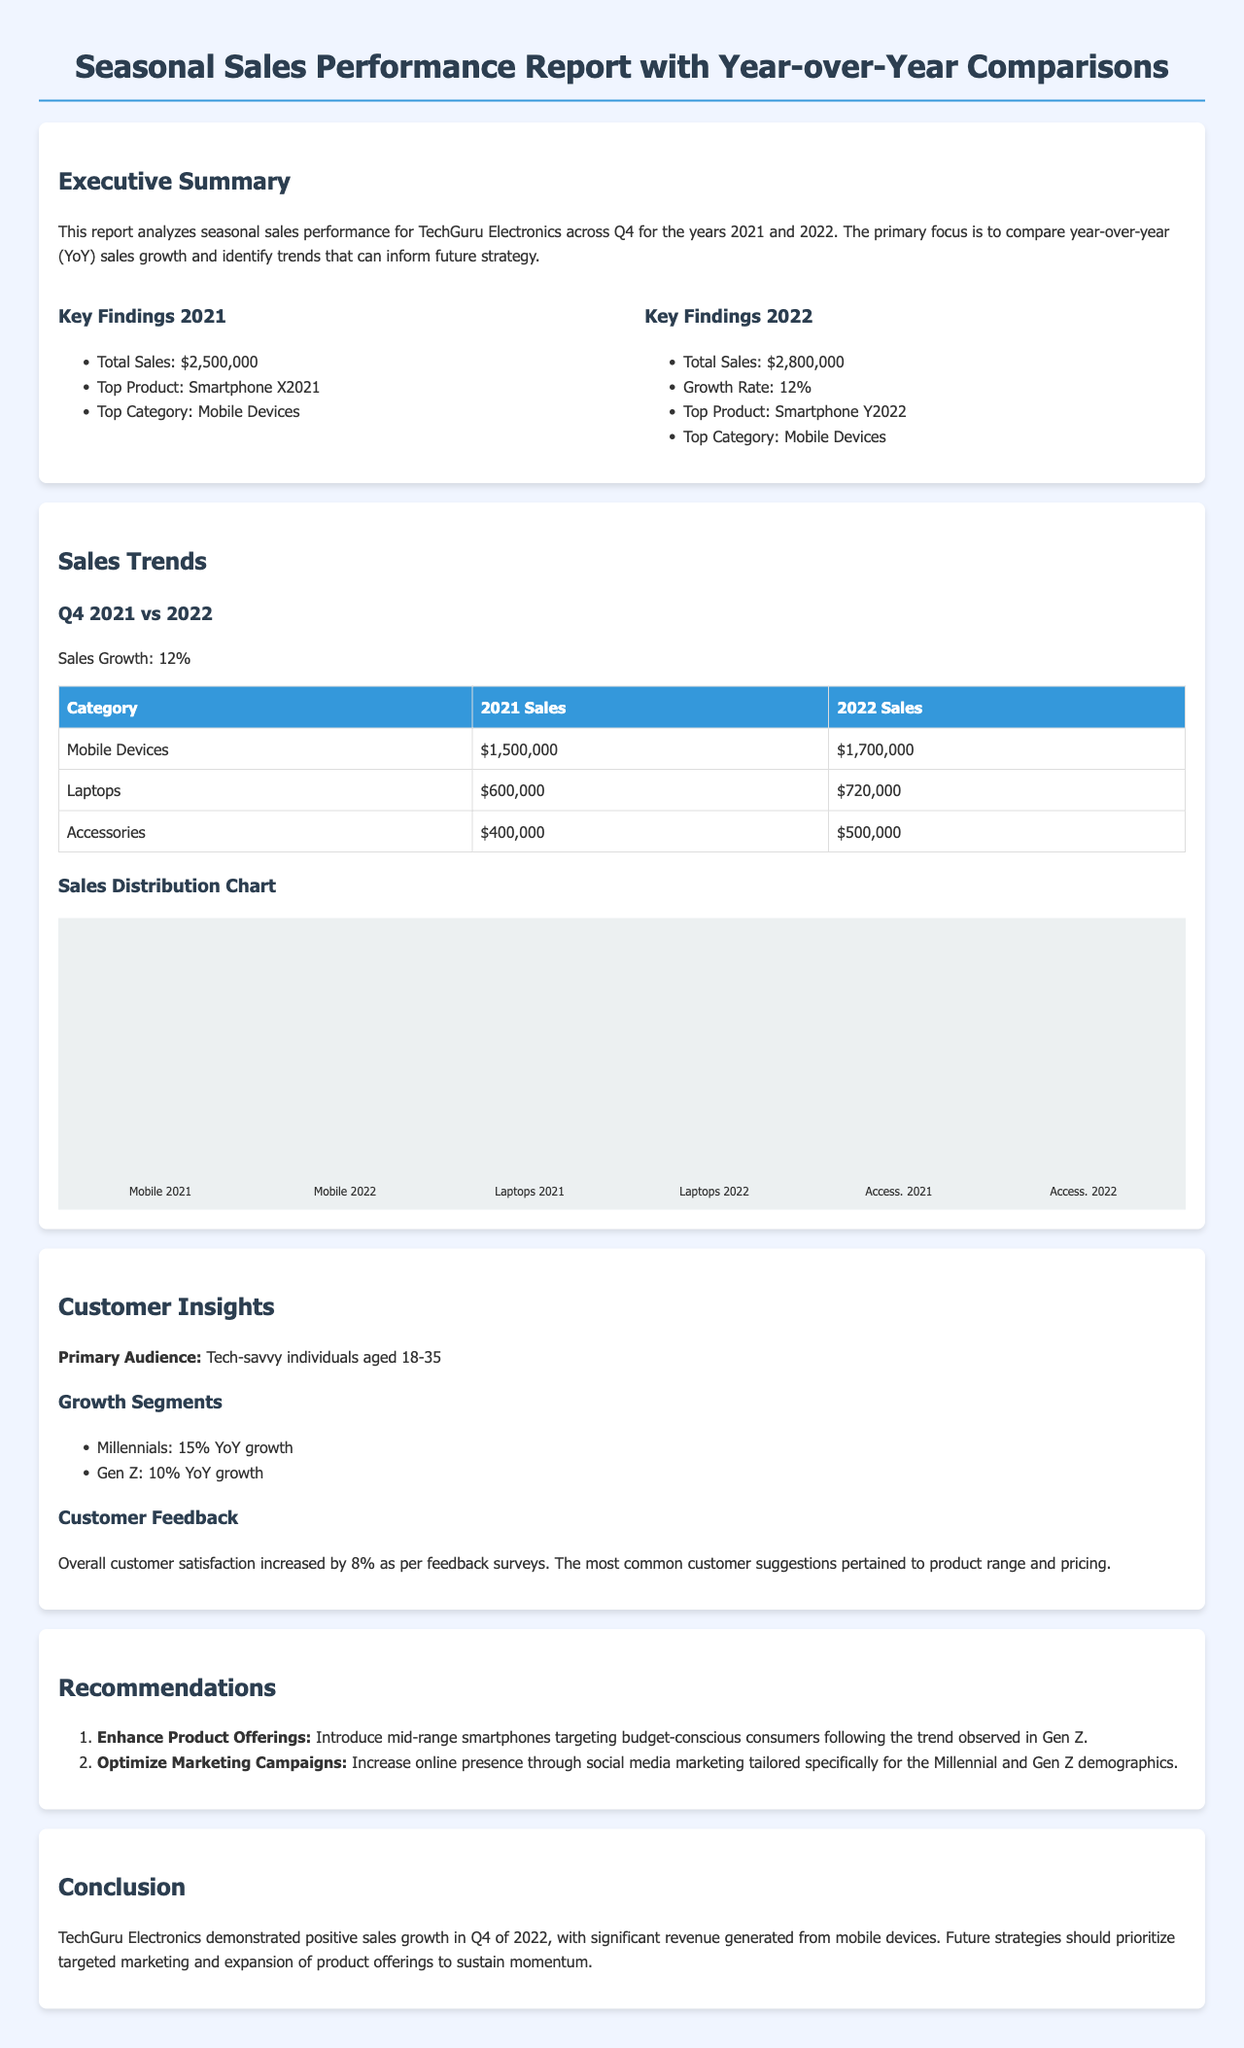What is the total sales in 2021? The total sales for 2021 is explicitly stated in the document as $2,500,000.
Answer: $2,500,000 What is the growth rate in 2022? The document mentions a growth rate of 12% for the year 2022.
Answer: 12% What was the top product in 2022? The report identifies "Smartphone Y2022" as the top product for the year 2022.
Answer: Smartphone Y2022 Which category had the highest sales in 2022? The table shows "Mobile Devices" had the highest sales of $1,700,000 in 2022.
Answer: Mobile Devices What was the overall customer satisfaction increase? According to the customer feedback section, overall customer satisfaction increased by 8%.
Answer: 8% What is the primary audience? The document specifies that the primary audience is "Tech-savvy individuals aged 18-35."
Answer: Tech-savvy individuals aged 18-35 What is one recommendation given in the report? The report recommends enhancing product offerings to target budget-conscious consumers.
Answer: Enhance Product Offerings How much did accessories sales increase from 2021 to 2022? The sales for Accessories increased from $400,000 in 2021 to $500,000 in 2022, an increase of $100,000.
Answer: $100,000 What is the total sales growth from Q4 2021 to Q4 2022? The document indicates the total sales growth from Q4 2021 to Q4 2022 is 12%.
Answer: 12% 